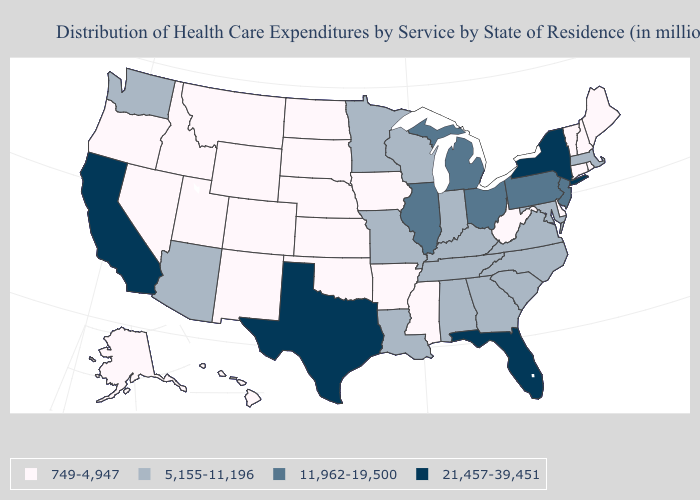What is the value of Vermont?
Keep it brief. 749-4,947. Name the states that have a value in the range 11,962-19,500?
Write a very short answer. Illinois, Michigan, New Jersey, Ohio, Pennsylvania. Among the states that border Delaware , which have the highest value?
Short answer required. New Jersey, Pennsylvania. Does the first symbol in the legend represent the smallest category?
Short answer required. Yes. Is the legend a continuous bar?
Concise answer only. No. Name the states that have a value in the range 749-4,947?
Quick response, please. Alaska, Arkansas, Colorado, Connecticut, Delaware, Hawaii, Idaho, Iowa, Kansas, Maine, Mississippi, Montana, Nebraska, Nevada, New Hampshire, New Mexico, North Dakota, Oklahoma, Oregon, Rhode Island, South Dakota, Utah, Vermont, West Virginia, Wyoming. What is the highest value in the MidWest ?
Give a very brief answer. 11,962-19,500. What is the highest value in the West ?
Write a very short answer. 21,457-39,451. What is the highest value in the MidWest ?
Give a very brief answer. 11,962-19,500. Does Mississippi have the lowest value in the South?
Keep it brief. Yes. Among the states that border Vermont , which have the lowest value?
Be succinct. New Hampshire. Name the states that have a value in the range 5,155-11,196?
Short answer required. Alabama, Arizona, Georgia, Indiana, Kentucky, Louisiana, Maryland, Massachusetts, Minnesota, Missouri, North Carolina, South Carolina, Tennessee, Virginia, Washington, Wisconsin. Name the states that have a value in the range 21,457-39,451?
Write a very short answer. California, Florida, New York, Texas. Among the states that border Oklahoma , does Kansas have the highest value?
Answer briefly. No. 